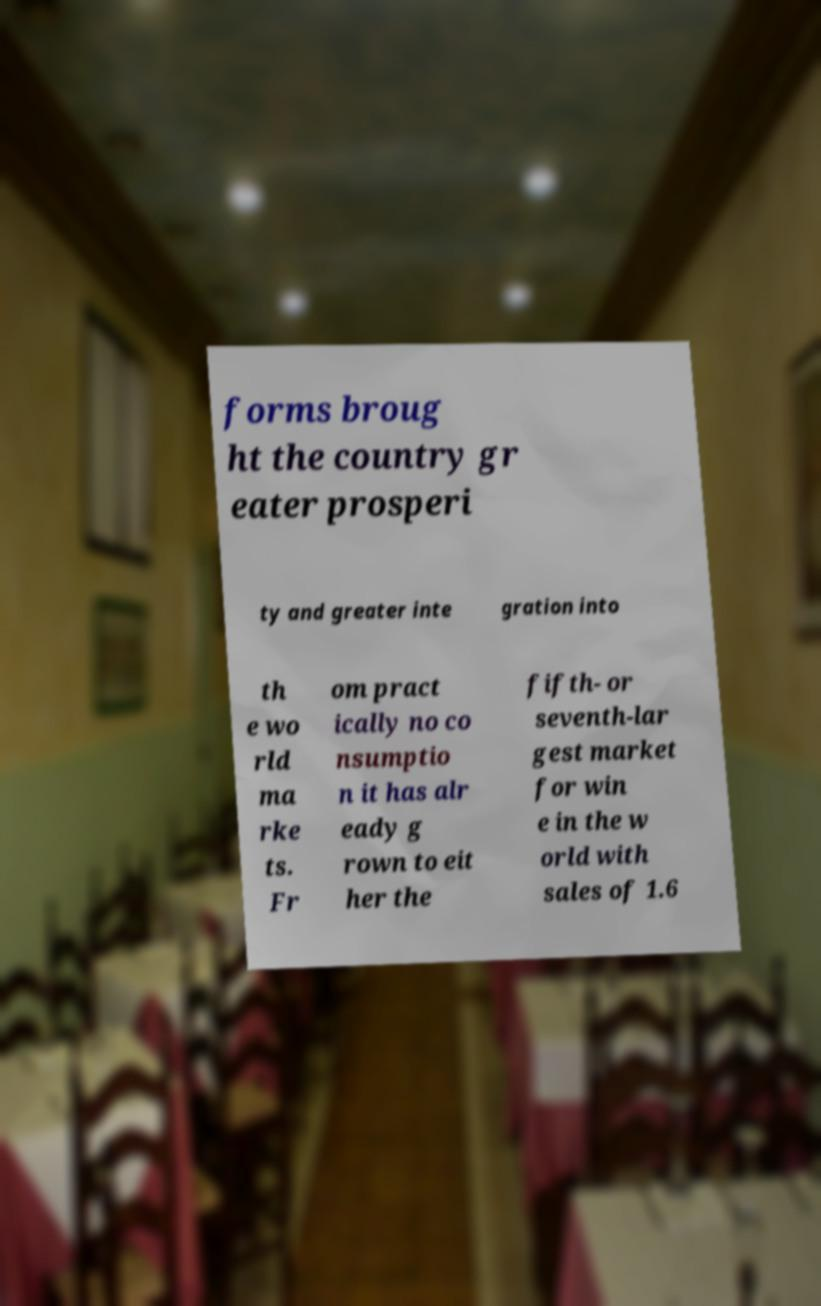There's text embedded in this image that I need extracted. Can you transcribe it verbatim? forms broug ht the country gr eater prosperi ty and greater inte gration into th e wo rld ma rke ts. Fr om pract ically no co nsumptio n it has alr eady g rown to eit her the fifth- or seventh-lar gest market for win e in the w orld with sales of 1.6 